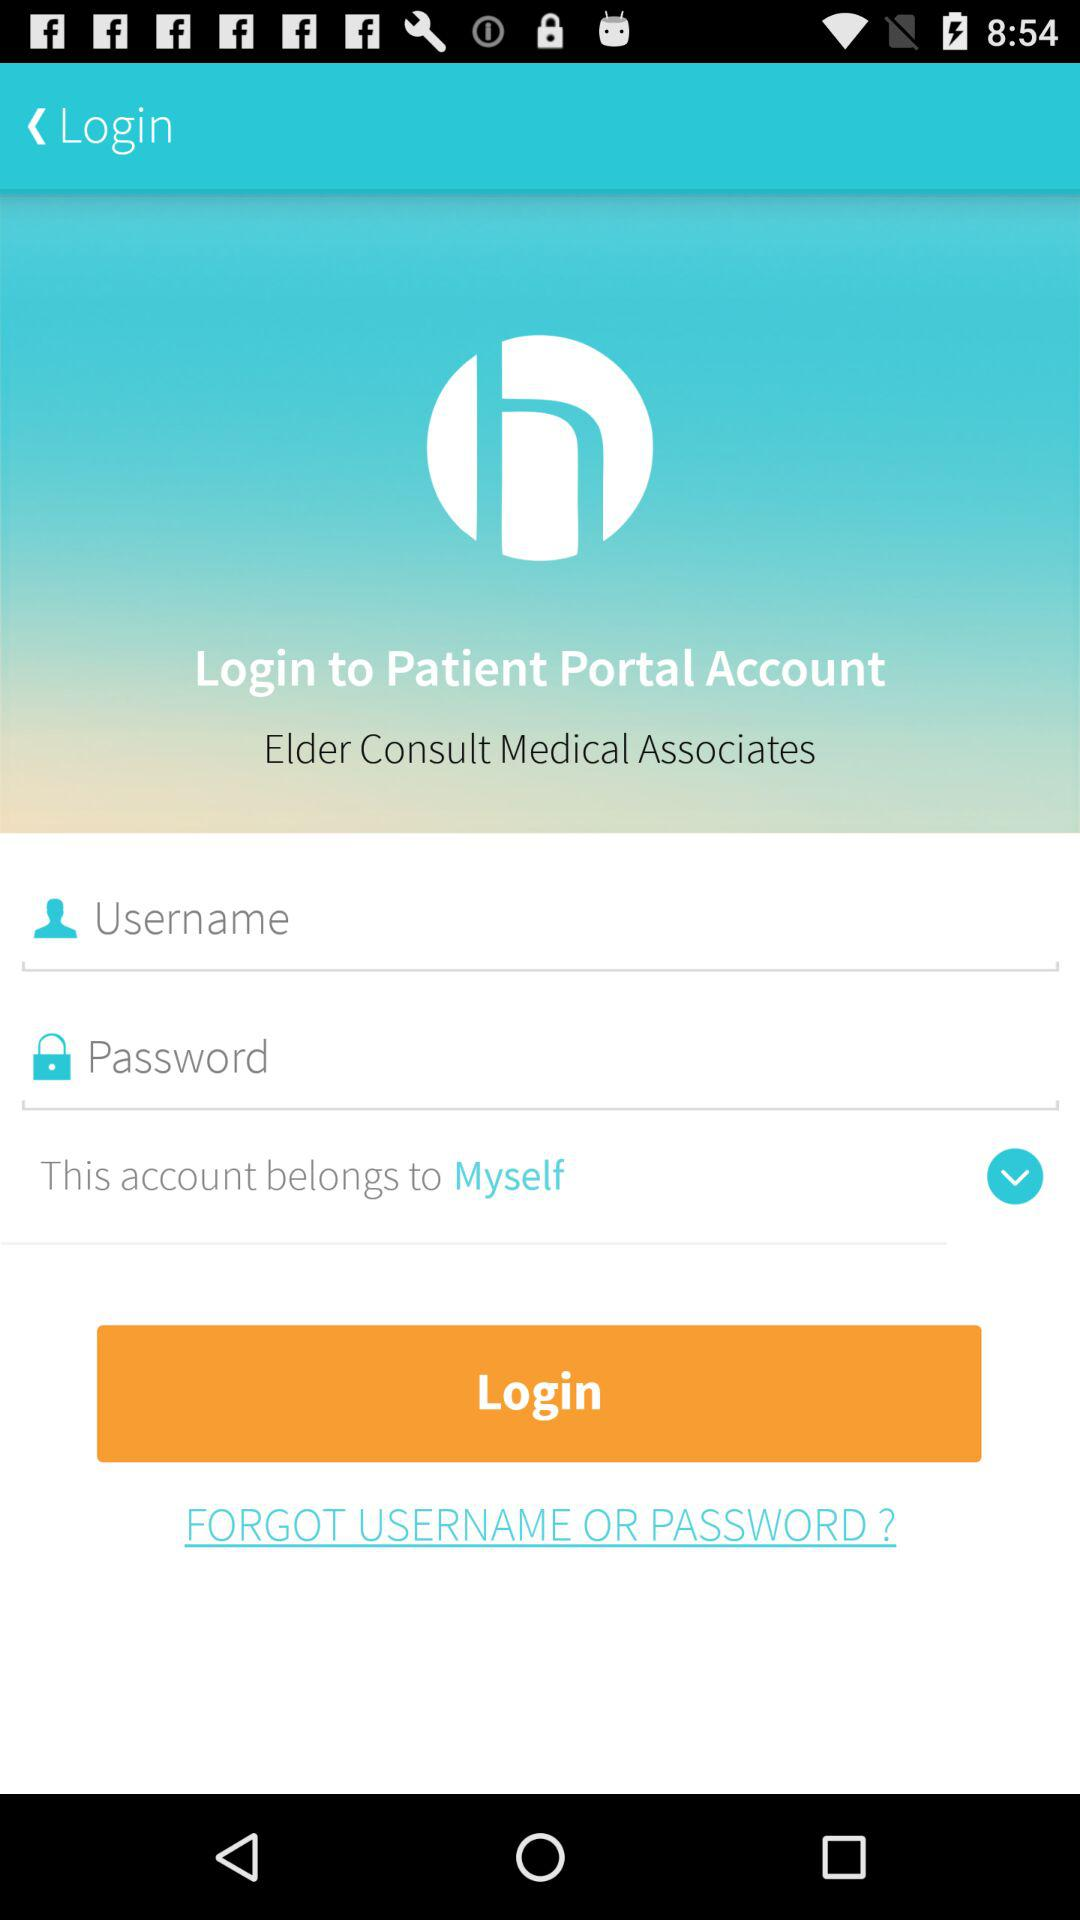What is the name of the company? The name of the company is "Healow". 